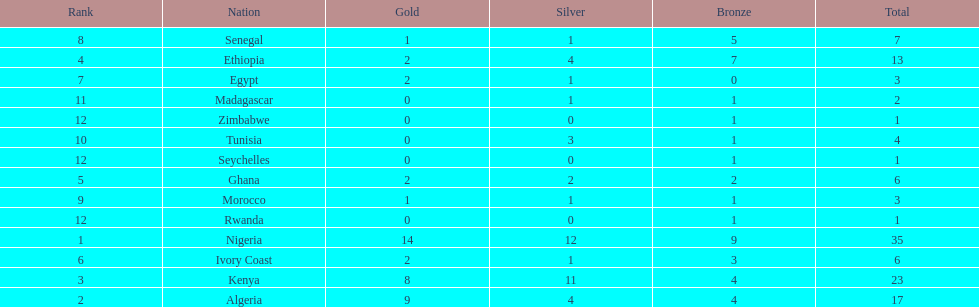Which nations have won only one medal? Rwanda, Zimbabwe, Seychelles. 